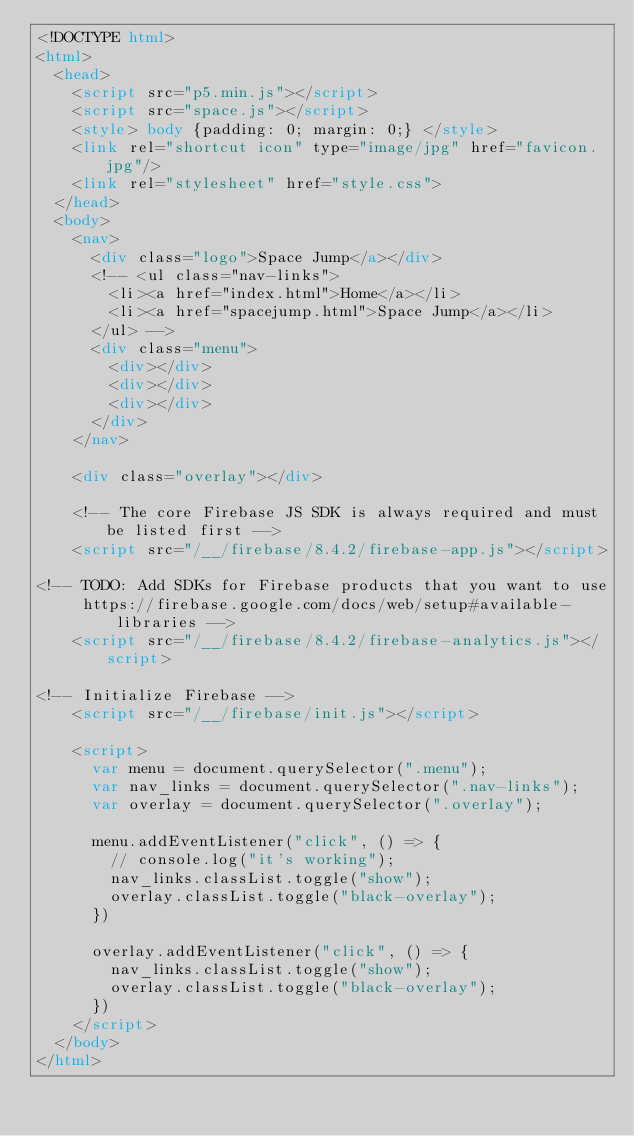Convert code to text. <code><loc_0><loc_0><loc_500><loc_500><_HTML_><!DOCTYPE html>
<html>
  <head>
    <script src="p5.min.js"></script>
    <script src="space.js"></script>
    <style> body {padding: 0; margin: 0;} </style>
    <link rel="shortcut icon" type="image/jpg" href="favicon.jpg"/>
    <link rel="stylesheet" href="style.css">
  </head>
  <body>
    <nav>
      <div class="logo">Space Jump</a></div>
      <!-- <ul class="nav-links">
        <li><a href="index.html">Home</a></li>  
        <li><a href="spacejump.html">Space Jump</a></li>
      </ul> -->
      <div class="menu">
        <div></div>
        <div></div>
        <div></div>
      </div>
    </nav>

    <div class="overlay"></div>

    <!-- The core Firebase JS SDK is always required and must be listed first -->
    <script src="/__/firebase/8.4.2/firebase-app.js"></script>

<!-- TODO: Add SDKs for Firebase products that you want to use
     https://firebase.google.com/docs/web/setup#available-libraries -->
    <script src="/__/firebase/8.4.2/firebase-analytics.js"></script>

<!-- Initialize Firebase -->
    <script src="/__/firebase/init.js"></script>

    <script>
      var menu = document.querySelector(".menu");
      var nav_links = document.querySelector(".nav-links");
      var overlay = document.querySelector(".overlay");

      menu.addEventListener("click", () => {
        // console.log("it's working");
        nav_links.classList.toggle("show");
        overlay.classList.toggle("black-overlay");
      })

      overlay.addEventListener("click", () => {
        nav_links.classList.toggle("show");
        overlay.classList.toggle("black-overlay");
      })
    </script>
  </body>
</html></code> 